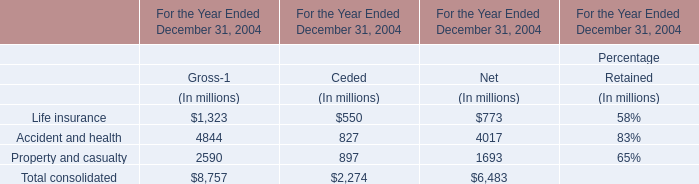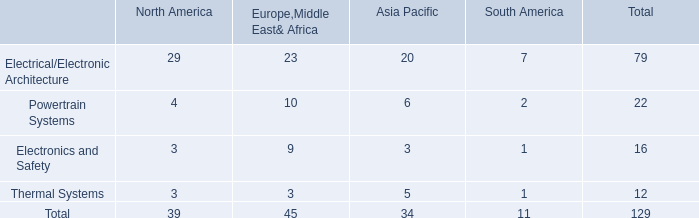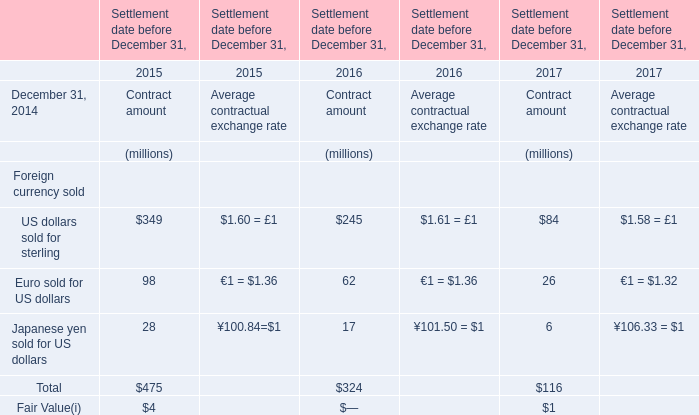What is the sum of Contract amount in 2015? (in million) 
Computations: (((349 + 98) + 28) + 4)
Answer: 479.0. 